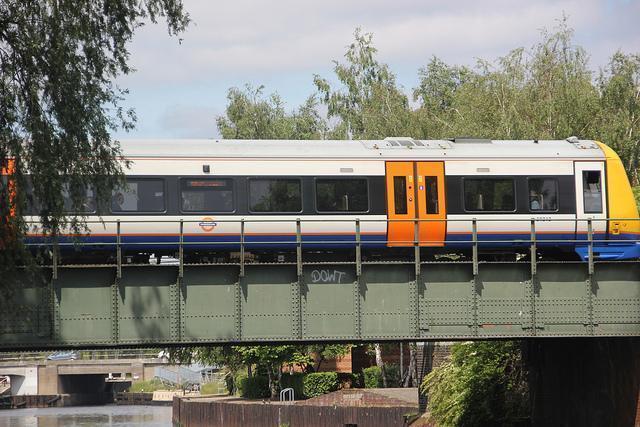The train gliding on what in order to move?
Choose the correct response, then elucidate: 'Answer: answer
Rationale: rationale.'
Options: Rails, wheels, bridge, station. Answer: rails.
Rationale: An elevated train is seen moving along a metal bridge. trains run along tracks or rails. 